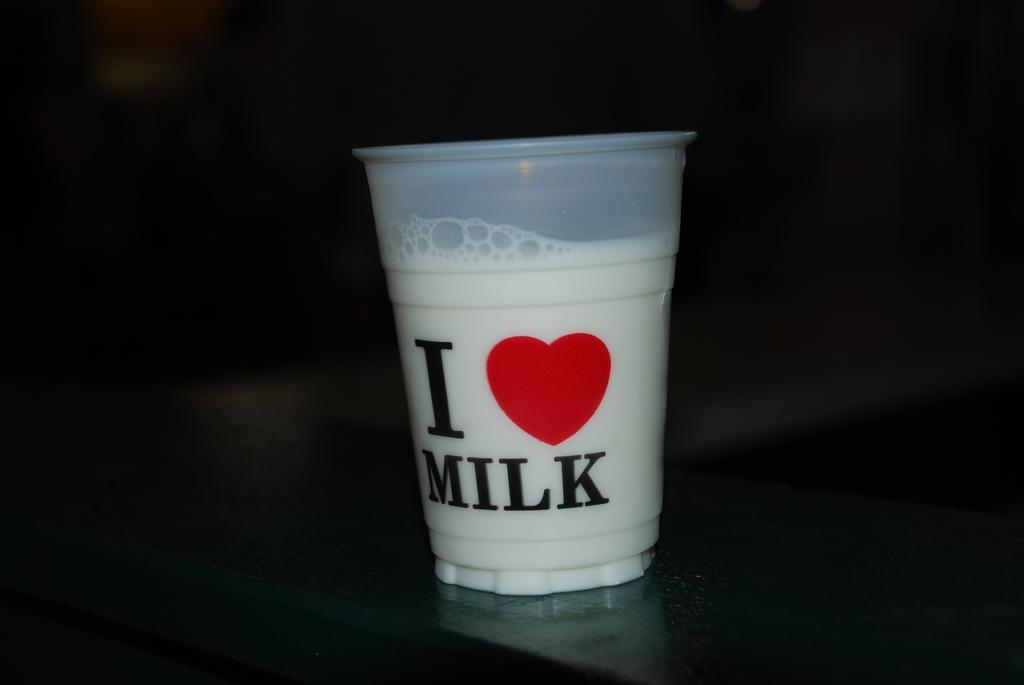<image>
Relay a brief, clear account of the picture shown. A glass of milk has been poured into a plastic cup that says " I love milk" 